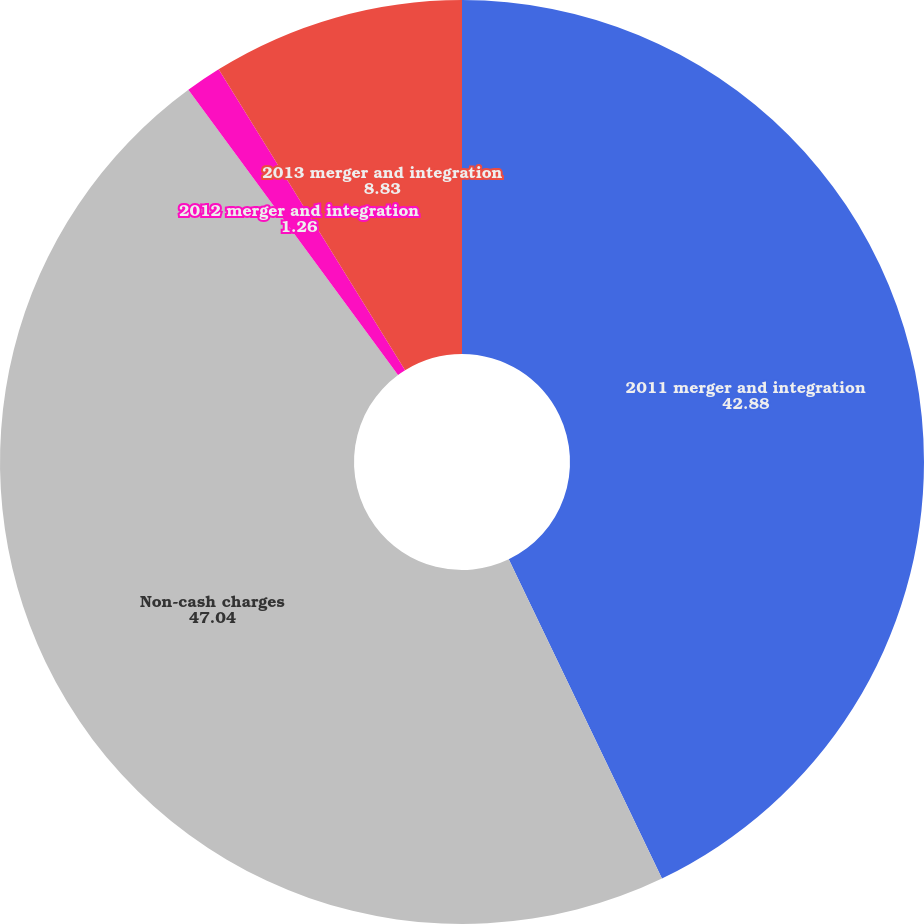Convert chart. <chart><loc_0><loc_0><loc_500><loc_500><pie_chart><fcel>2011 merger and integration<fcel>Non-cash charges<fcel>2012 merger and integration<fcel>2013 merger and integration<nl><fcel>42.88%<fcel>47.04%<fcel>1.26%<fcel>8.83%<nl></chart> 